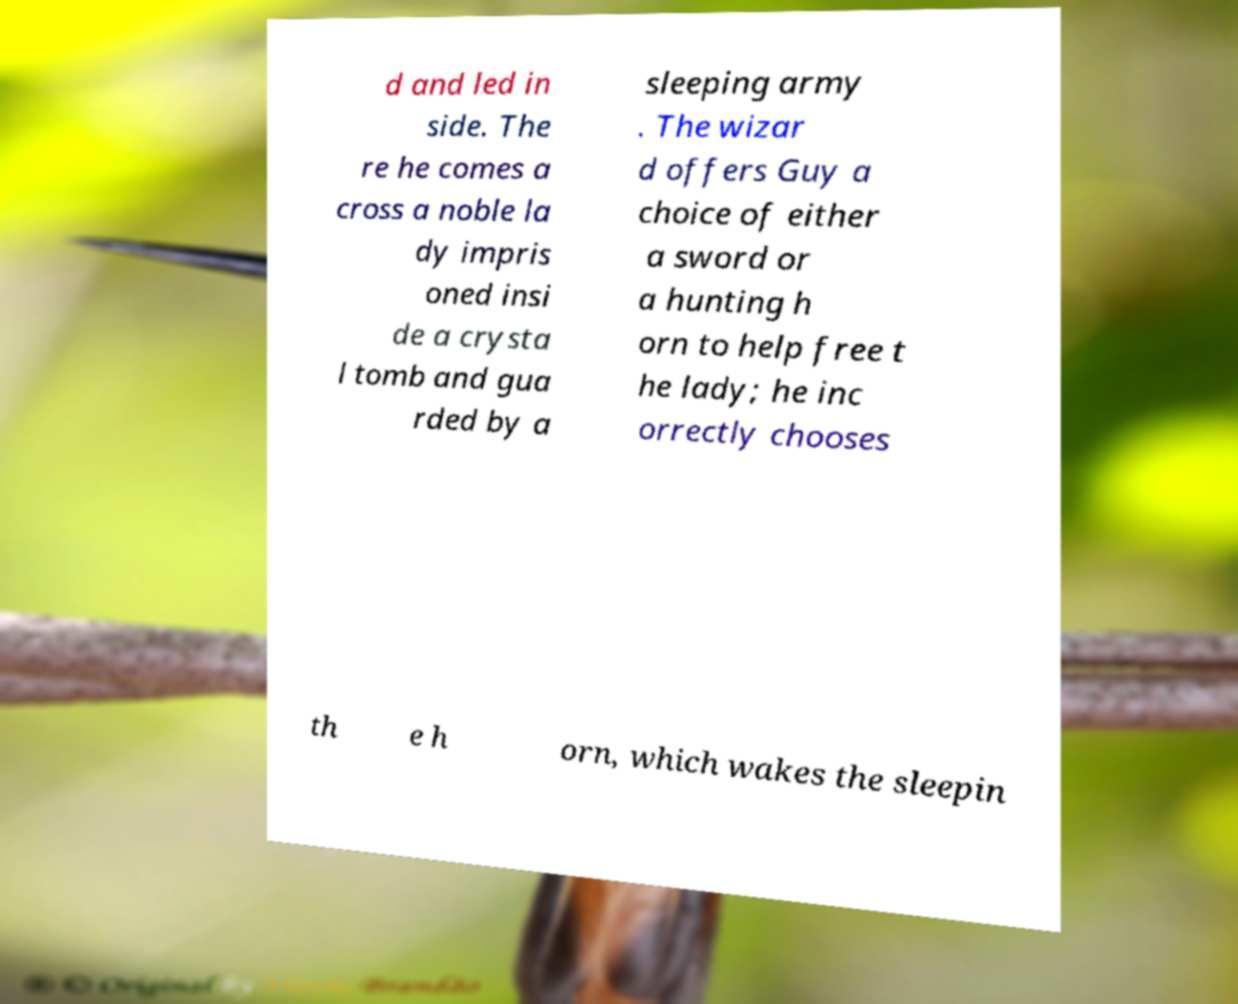Please read and relay the text visible in this image. What does it say? d and led in side. The re he comes a cross a noble la dy impris oned insi de a crysta l tomb and gua rded by a sleeping army . The wizar d offers Guy a choice of either a sword or a hunting h orn to help free t he lady; he inc orrectly chooses th e h orn, which wakes the sleepin 